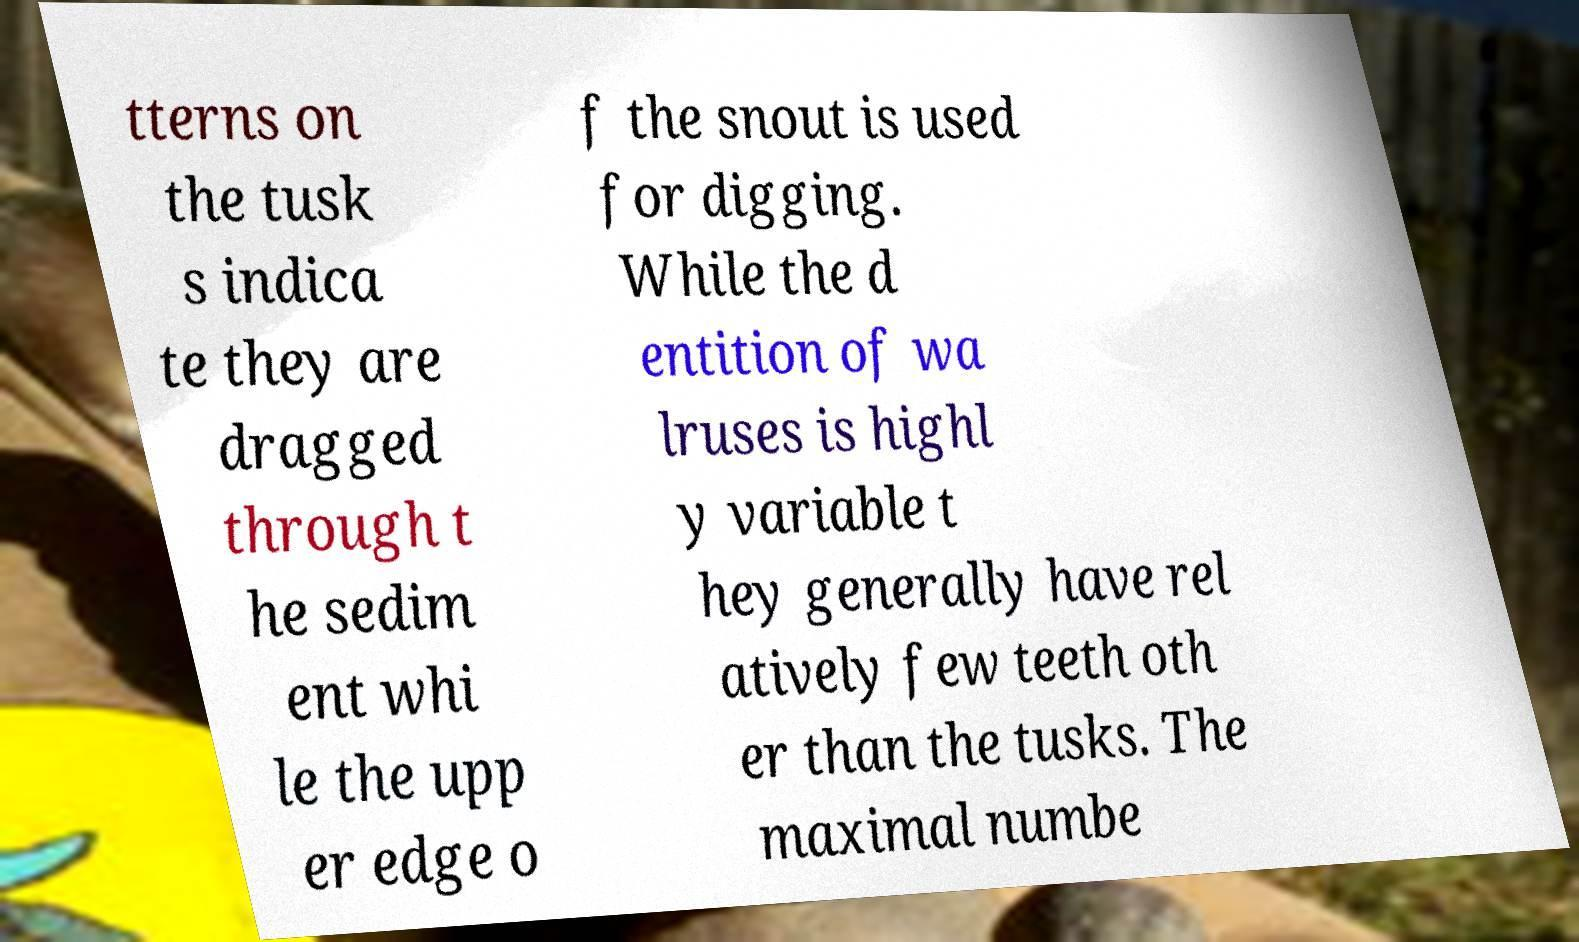Could you assist in decoding the text presented in this image and type it out clearly? tterns on the tusk s indica te they are dragged through t he sedim ent whi le the upp er edge o f the snout is used for digging. While the d entition of wa lruses is highl y variable t hey generally have rel atively few teeth oth er than the tusks. The maximal numbe 